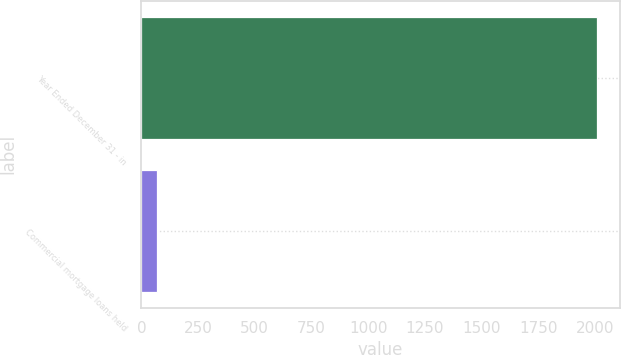Convert chart. <chart><loc_0><loc_0><loc_500><loc_500><bar_chart><fcel>Year Ended December 31 - in<fcel>Commercial mortgage loans held<nl><fcel>2009<fcel>68<nl></chart> 